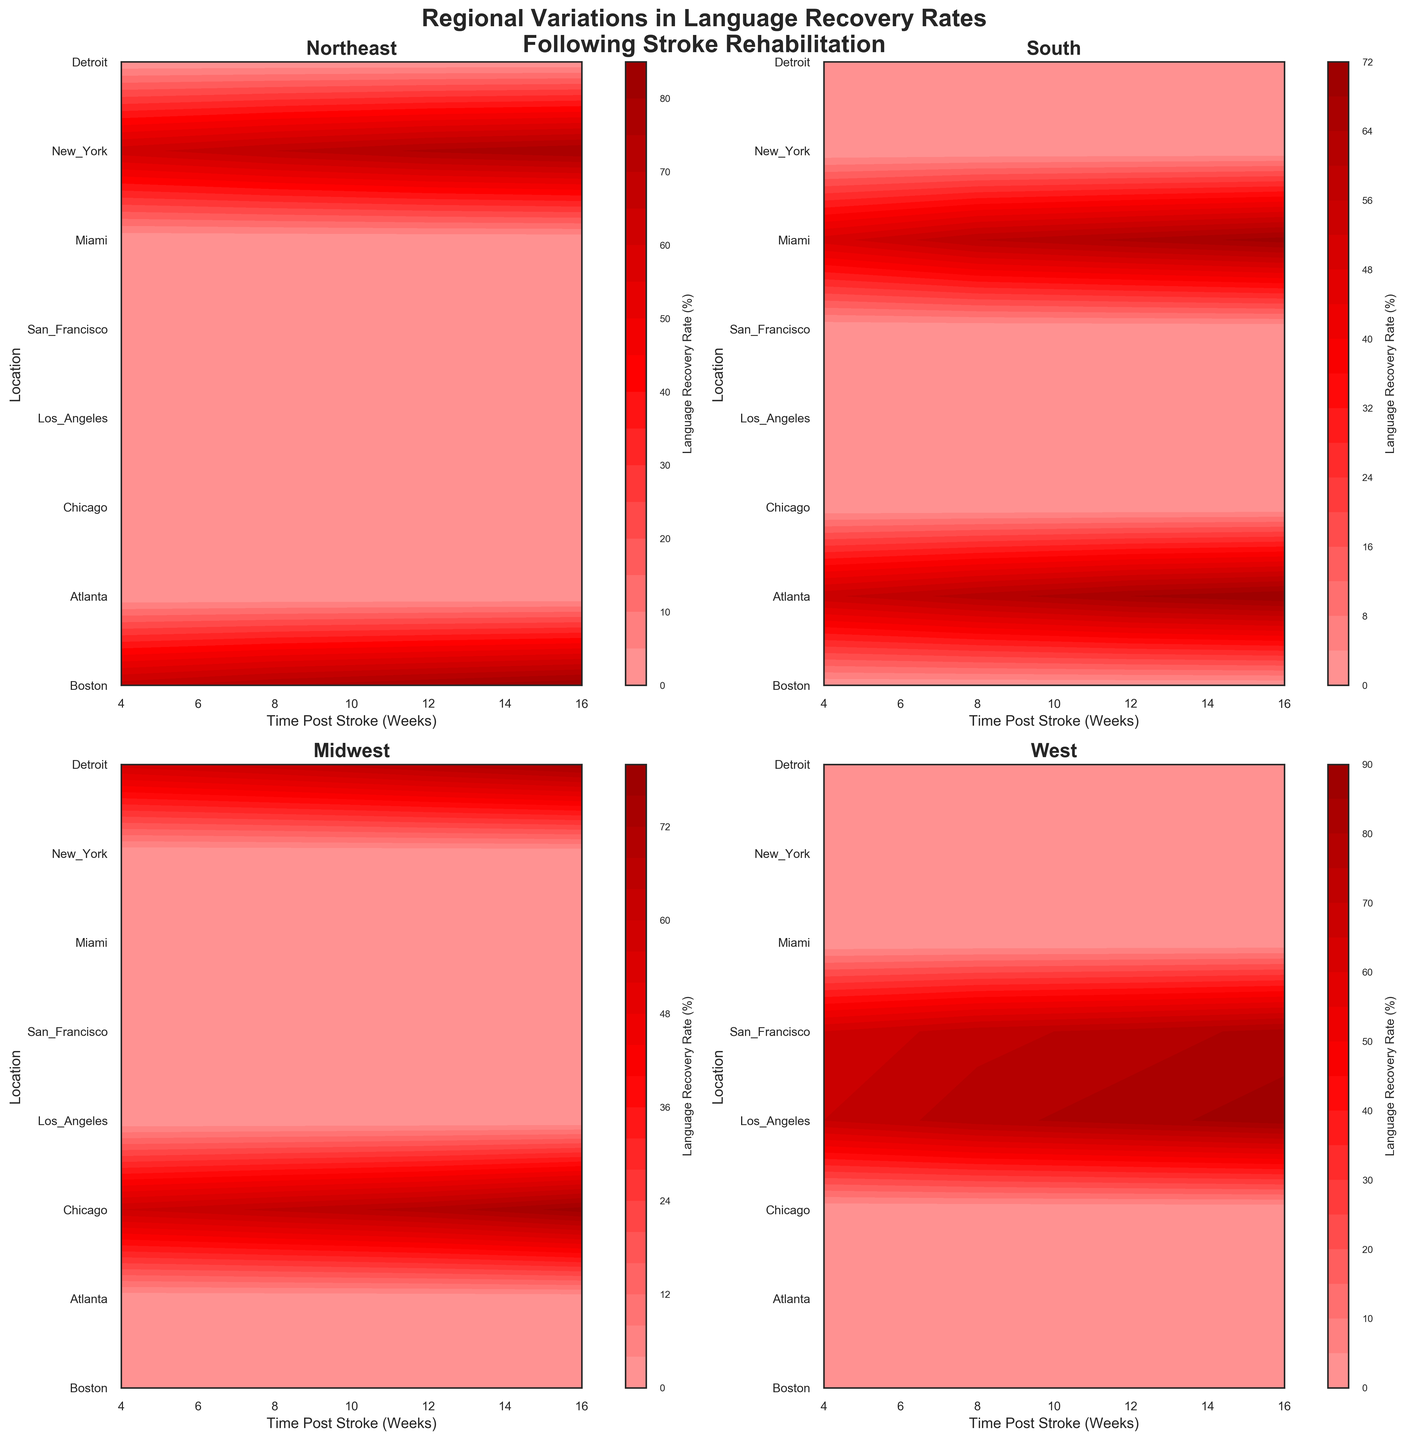What's the title of the chart? At the top of the chart, in a larger and bold font, the title reads: "Regional Variations in Language Recovery Rates Following Stroke Rehabilitation".
Answer: Regional Variations in Language Recovery Rates Following Stroke Rehabilitation How many regions are compared in this figure? The figure has four subplots, each representing a different region: Northeast, South, Midwest, and West.
Answer: 4 Which region shows the highest language recovery rate at 16 weeks post-stroke? By observing the color gradients in the subplots, the West region consistently shows the darkest red, indicating the highest recovery rate at 16 weeks, with values around 88%.
Answer: West How does the language recovery rate in Boston at 4 weeks compare to that in Miami at 4 weeks? Looking at the contour plots, both Boston in the Northeast and Miami in the South exhibit different shades of red. Boston has a recovery rate of 68%, while Miami shows 50%, making Boston's rate significantly higher.
Answer: Boston is higher Which location in the West shows a slower initial recovery rate at 4 weeks, Los Angeles or San Francisco? By comparing the 4-week recovery rates between Los Angeles and San Francisco in the West subplot, Los Angeles has a rate of 70%, whereas San Francisco has a rate of 65%. Therefore, San Francisco has a slower initial recovery rate.
Answer: San Francisco Which time point shows the most improvement in language recovery rates in Chicago between 4 and 16 weeks? By examining the gradation of colors in Chicago's plot in the Midwest region, the recovery rate at 4 weeks is 60%, and at 16 weeks, it is 78%. The largest improvement is observed from 4 to 16 weeks, showing an increase of 18%.
Answer: Between 4 and 16 weeks What is the trend in language recovery rates over time in the South region? Observing the South region subplot, where Atlanta and Miami are plotted, there is a clear increasing trend: darker red colors develop from 4 to 16 weeks, indicating recovery rates are improving over time.
Answer: Increasing Compare the 12-week recovery rates between New York in the Northeast and Detroit in the Midwest. In the respective subplots for Northeast and Midwest, New York shows a recovery rate of 76%, and Detroit shows a recovery rate of 69% at 12 weeks. Thus, New York has a higher recovery rate at this time.
Answer: New York is higher 